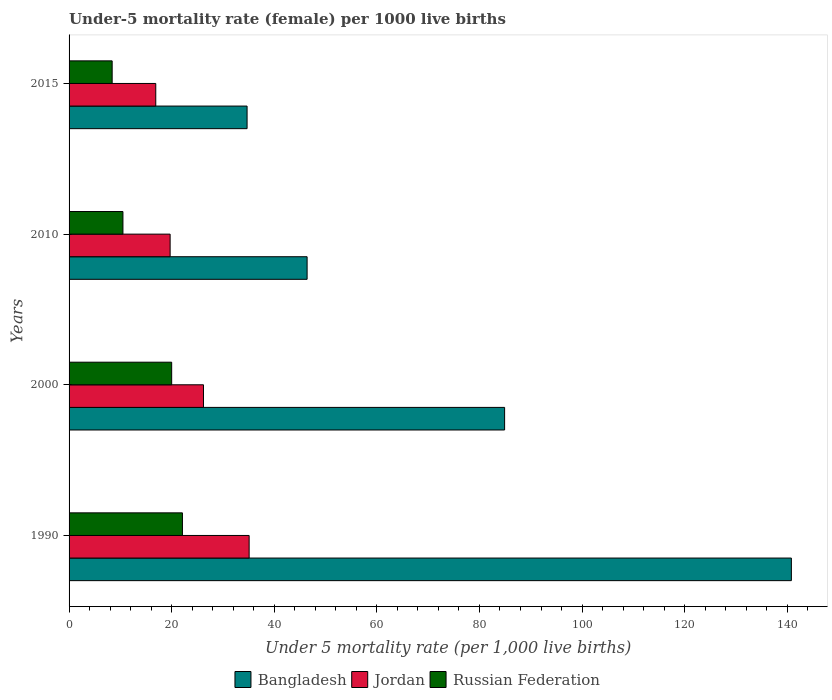How many different coloured bars are there?
Provide a succinct answer. 3. How many groups of bars are there?
Your answer should be very brief. 4. How many bars are there on the 1st tick from the top?
Give a very brief answer. 3. What is the under-five mortality rate in Bangladesh in 2015?
Keep it short and to the point. 34.7. Across all years, what is the maximum under-five mortality rate in Bangladesh?
Your answer should be compact. 140.8. In which year was the under-five mortality rate in Jordan minimum?
Offer a very short reply. 2015. What is the difference between the under-five mortality rate in Russian Federation in 1990 and that in 2000?
Keep it short and to the point. 2.1. What is the difference between the under-five mortality rate in Jordan in 1990 and the under-five mortality rate in Bangladesh in 2010?
Provide a short and direct response. -11.3. What is the average under-five mortality rate in Russian Federation per year?
Give a very brief answer. 15.25. In the year 2000, what is the difference between the under-five mortality rate in Russian Federation and under-five mortality rate in Jordan?
Your answer should be compact. -6.2. What is the ratio of the under-five mortality rate in Bangladesh in 1990 to that in 2015?
Your answer should be very brief. 4.06. Is the under-five mortality rate in Jordan in 1990 less than that in 2000?
Ensure brevity in your answer.  No. What is the difference between the highest and the second highest under-five mortality rate in Russian Federation?
Make the answer very short. 2.1. What is the difference between the highest and the lowest under-five mortality rate in Jordan?
Offer a terse response. 18.2. Is the sum of the under-five mortality rate in Russian Federation in 1990 and 2000 greater than the maximum under-five mortality rate in Bangladesh across all years?
Ensure brevity in your answer.  No. What does the 2nd bar from the top in 2010 represents?
Provide a succinct answer. Jordan. What is the difference between two consecutive major ticks on the X-axis?
Offer a very short reply. 20. Are the values on the major ticks of X-axis written in scientific E-notation?
Provide a short and direct response. No. Where does the legend appear in the graph?
Your answer should be compact. Bottom center. How are the legend labels stacked?
Provide a succinct answer. Horizontal. What is the title of the graph?
Offer a terse response. Under-5 mortality rate (female) per 1000 live births. Does "Mozambique" appear as one of the legend labels in the graph?
Give a very brief answer. No. What is the label or title of the X-axis?
Make the answer very short. Under 5 mortality rate (per 1,0 live births). What is the Under 5 mortality rate (per 1,000 live births) of Bangladesh in 1990?
Provide a succinct answer. 140.8. What is the Under 5 mortality rate (per 1,000 live births) of Jordan in 1990?
Make the answer very short. 35.1. What is the Under 5 mortality rate (per 1,000 live births) in Russian Federation in 1990?
Give a very brief answer. 22.1. What is the Under 5 mortality rate (per 1,000 live births) of Bangladesh in 2000?
Make the answer very short. 84.9. What is the Under 5 mortality rate (per 1,000 live births) of Jordan in 2000?
Your response must be concise. 26.2. What is the Under 5 mortality rate (per 1,000 live births) of Russian Federation in 2000?
Ensure brevity in your answer.  20. What is the Under 5 mortality rate (per 1,000 live births) of Bangladesh in 2010?
Provide a succinct answer. 46.4. What is the Under 5 mortality rate (per 1,000 live births) of Jordan in 2010?
Ensure brevity in your answer.  19.7. What is the Under 5 mortality rate (per 1,000 live births) in Bangladesh in 2015?
Make the answer very short. 34.7. What is the Under 5 mortality rate (per 1,000 live births) in Jordan in 2015?
Your response must be concise. 16.9. Across all years, what is the maximum Under 5 mortality rate (per 1,000 live births) in Bangladesh?
Your answer should be compact. 140.8. Across all years, what is the maximum Under 5 mortality rate (per 1,000 live births) of Jordan?
Keep it short and to the point. 35.1. Across all years, what is the maximum Under 5 mortality rate (per 1,000 live births) in Russian Federation?
Keep it short and to the point. 22.1. Across all years, what is the minimum Under 5 mortality rate (per 1,000 live births) in Bangladesh?
Provide a succinct answer. 34.7. Across all years, what is the minimum Under 5 mortality rate (per 1,000 live births) of Russian Federation?
Make the answer very short. 8.4. What is the total Under 5 mortality rate (per 1,000 live births) in Bangladesh in the graph?
Your answer should be very brief. 306.8. What is the total Under 5 mortality rate (per 1,000 live births) in Jordan in the graph?
Keep it short and to the point. 97.9. What is the difference between the Under 5 mortality rate (per 1,000 live births) in Bangladesh in 1990 and that in 2000?
Offer a very short reply. 55.9. What is the difference between the Under 5 mortality rate (per 1,000 live births) in Jordan in 1990 and that in 2000?
Your response must be concise. 8.9. What is the difference between the Under 5 mortality rate (per 1,000 live births) in Bangladesh in 1990 and that in 2010?
Your answer should be very brief. 94.4. What is the difference between the Under 5 mortality rate (per 1,000 live births) in Russian Federation in 1990 and that in 2010?
Give a very brief answer. 11.6. What is the difference between the Under 5 mortality rate (per 1,000 live births) of Bangladesh in 1990 and that in 2015?
Provide a short and direct response. 106.1. What is the difference between the Under 5 mortality rate (per 1,000 live births) in Russian Federation in 1990 and that in 2015?
Make the answer very short. 13.7. What is the difference between the Under 5 mortality rate (per 1,000 live births) of Bangladesh in 2000 and that in 2010?
Ensure brevity in your answer.  38.5. What is the difference between the Under 5 mortality rate (per 1,000 live births) of Jordan in 2000 and that in 2010?
Your answer should be very brief. 6.5. What is the difference between the Under 5 mortality rate (per 1,000 live births) in Bangladesh in 2000 and that in 2015?
Make the answer very short. 50.2. What is the difference between the Under 5 mortality rate (per 1,000 live births) in Russian Federation in 2000 and that in 2015?
Give a very brief answer. 11.6. What is the difference between the Under 5 mortality rate (per 1,000 live births) in Bangladesh in 2010 and that in 2015?
Give a very brief answer. 11.7. What is the difference between the Under 5 mortality rate (per 1,000 live births) in Bangladesh in 1990 and the Under 5 mortality rate (per 1,000 live births) in Jordan in 2000?
Offer a very short reply. 114.6. What is the difference between the Under 5 mortality rate (per 1,000 live births) in Bangladesh in 1990 and the Under 5 mortality rate (per 1,000 live births) in Russian Federation in 2000?
Ensure brevity in your answer.  120.8. What is the difference between the Under 5 mortality rate (per 1,000 live births) in Bangladesh in 1990 and the Under 5 mortality rate (per 1,000 live births) in Jordan in 2010?
Provide a short and direct response. 121.1. What is the difference between the Under 5 mortality rate (per 1,000 live births) in Bangladesh in 1990 and the Under 5 mortality rate (per 1,000 live births) in Russian Federation in 2010?
Give a very brief answer. 130.3. What is the difference between the Under 5 mortality rate (per 1,000 live births) in Jordan in 1990 and the Under 5 mortality rate (per 1,000 live births) in Russian Federation in 2010?
Provide a short and direct response. 24.6. What is the difference between the Under 5 mortality rate (per 1,000 live births) in Bangladesh in 1990 and the Under 5 mortality rate (per 1,000 live births) in Jordan in 2015?
Offer a very short reply. 123.9. What is the difference between the Under 5 mortality rate (per 1,000 live births) in Bangladesh in 1990 and the Under 5 mortality rate (per 1,000 live births) in Russian Federation in 2015?
Provide a short and direct response. 132.4. What is the difference between the Under 5 mortality rate (per 1,000 live births) in Jordan in 1990 and the Under 5 mortality rate (per 1,000 live births) in Russian Federation in 2015?
Offer a terse response. 26.7. What is the difference between the Under 5 mortality rate (per 1,000 live births) of Bangladesh in 2000 and the Under 5 mortality rate (per 1,000 live births) of Jordan in 2010?
Provide a succinct answer. 65.2. What is the difference between the Under 5 mortality rate (per 1,000 live births) of Bangladesh in 2000 and the Under 5 mortality rate (per 1,000 live births) of Russian Federation in 2010?
Offer a very short reply. 74.4. What is the difference between the Under 5 mortality rate (per 1,000 live births) in Bangladesh in 2000 and the Under 5 mortality rate (per 1,000 live births) in Russian Federation in 2015?
Your answer should be compact. 76.5. What is the difference between the Under 5 mortality rate (per 1,000 live births) in Bangladesh in 2010 and the Under 5 mortality rate (per 1,000 live births) in Jordan in 2015?
Offer a very short reply. 29.5. What is the average Under 5 mortality rate (per 1,000 live births) of Bangladesh per year?
Provide a short and direct response. 76.7. What is the average Under 5 mortality rate (per 1,000 live births) of Jordan per year?
Offer a very short reply. 24.48. What is the average Under 5 mortality rate (per 1,000 live births) of Russian Federation per year?
Give a very brief answer. 15.25. In the year 1990, what is the difference between the Under 5 mortality rate (per 1,000 live births) of Bangladesh and Under 5 mortality rate (per 1,000 live births) of Jordan?
Keep it short and to the point. 105.7. In the year 1990, what is the difference between the Under 5 mortality rate (per 1,000 live births) in Bangladesh and Under 5 mortality rate (per 1,000 live births) in Russian Federation?
Offer a very short reply. 118.7. In the year 1990, what is the difference between the Under 5 mortality rate (per 1,000 live births) in Jordan and Under 5 mortality rate (per 1,000 live births) in Russian Federation?
Make the answer very short. 13. In the year 2000, what is the difference between the Under 5 mortality rate (per 1,000 live births) in Bangladesh and Under 5 mortality rate (per 1,000 live births) in Jordan?
Your answer should be very brief. 58.7. In the year 2000, what is the difference between the Under 5 mortality rate (per 1,000 live births) in Bangladesh and Under 5 mortality rate (per 1,000 live births) in Russian Federation?
Your response must be concise. 64.9. In the year 2000, what is the difference between the Under 5 mortality rate (per 1,000 live births) in Jordan and Under 5 mortality rate (per 1,000 live births) in Russian Federation?
Offer a terse response. 6.2. In the year 2010, what is the difference between the Under 5 mortality rate (per 1,000 live births) of Bangladesh and Under 5 mortality rate (per 1,000 live births) of Jordan?
Your response must be concise. 26.7. In the year 2010, what is the difference between the Under 5 mortality rate (per 1,000 live births) of Bangladesh and Under 5 mortality rate (per 1,000 live births) of Russian Federation?
Ensure brevity in your answer.  35.9. In the year 2015, what is the difference between the Under 5 mortality rate (per 1,000 live births) of Bangladesh and Under 5 mortality rate (per 1,000 live births) of Jordan?
Offer a very short reply. 17.8. In the year 2015, what is the difference between the Under 5 mortality rate (per 1,000 live births) in Bangladesh and Under 5 mortality rate (per 1,000 live births) in Russian Federation?
Offer a terse response. 26.3. What is the ratio of the Under 5 mortality rate (per 1,000 live births) of Bangladesh in 1990 to that in 2000?
Your response must be concise. 1.66. What is the ratio of the Under 5 mortality rate (per 1,000 live births) in Jordan in 1990 to that in 2000?
Give a very brief answer. 1.34. What is the ratio of the Under 5 mortality rate (per 1,000 live births) in Russian Federation in 1990 to that in 2000?
Your answer should be compact. 1.1. What is the ratio of the Under 5 mortality rate (per 1,000 live births) in Bangladesh in 1990 to that in 2010?
Keep it short and to the point. 3.03. What is the ratio of the Under 5 mortality rate (per 1,000 live births) of Jordan in 1990 to that in 2010?
Provide a succinct answer. 1.78. What is the ratio of the Under 5 mortality rate (per 1,000 live births) of Russian Federation in 1990 to that in 2010?
Provide a short and direct response. 2.1. What is the ratio of the Under 5 mortality rate (per 1,000 live births) of Bangladesh in 1990 to that in 2015?
Keep it short and to the point. 4.06. What is the ratio of the Under 5 mortality rate (per 1,000 live births) of Jordan in 1990 to that in 2015?
Offer a terse response. 2.08. What is the ratio of the Under 5 mortality rate (per 1,000 live births) of Russian Federation in 1990 to that in 2015?
Your answer should be compact. 2.63. What is the ratio of the Under 5 mortality rate (per 1,000 live births) in Bangladesh in 2000 to that in 2010?
Provide a succinct answer. 1.83. What is the ratio of the Under 5 mortality rate (per 1,000 live births) of Jordan in 2000 to that in 2010?
Your answer should be very brief. 1.33. What is the ratio of the Under 5 mortality rate (per 1,000 live births) of Russian Federation in 2000 to that in 2010?
Keep it short and to the point. 1.9. What is the ratio of the Under 5 mortality rate (per 1,000 live births) of Bangladesh in 2000 to that in 2015?
Your answer should be very brief. 2.45. What is the ratio of the Under 5 mortality rate (per 1,000 live births) of Jordan in 2000 to that in 2015?
Offer a very short reply. 1.55. What is the ratio of the Under 5 mortality rate (per 1,000 live births) of Russian Federation in 2000 to that in 2015?
Give a very brief answer. 2.38. What is the ratio of the Under 5 mortality rate (per 1,000 live births) in Bangladesh in 2010 to that in 2015?
Offer a terse response. 1.34. What is the ratio of the Under 5 mortality rate (per 1,000 live births) of Jordan in 2010 to that in 2015?
Provide a short and direct response. 1.17. What is the difference between the highest and the second highest Under 5 mortality rate (per 1,000 live births) of Bangladesh?
Ensure brevity in your answer.  55.9. What is the difference between the highest and the lowest Under 5 mortality rate (per 1,000 live births) of Bangladesh?
Ensure brevity in your answer.  106.1. What is the difference between the highest and the lowest Under 5 mortality rate (per 1,000 live births) in Russian Federation?
Your response must be concise. 13.7. 